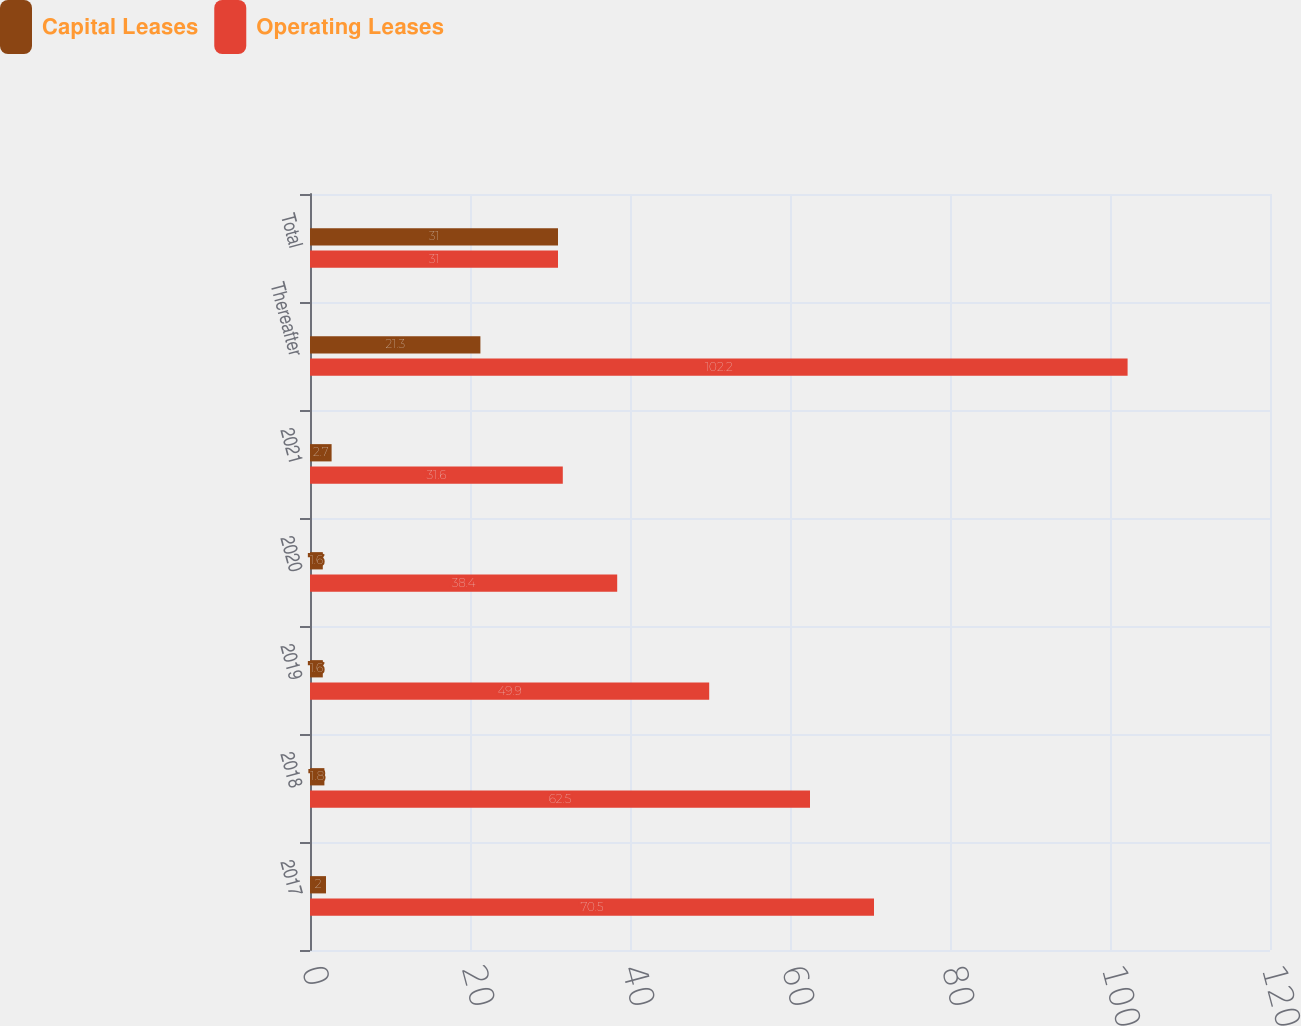Convert chart to OTSL. <chart><loc_0><loc_0><loc_500><loc_500><stacked_bar_chart><ecel><fcel>2017<fcel>2018<fcel>2019<fcel>2020<fcel>2021<fcel>Thereafter<fcel>Total<nl><fcel>Capital Leases<fcel>2<fcel>1.8<fcel>1.6<fcel>1.6<fcel>2.7<fcel>21.3<fcel>31<nl><fcel>Operating Leases<fcel>70.5<fcel>62.5<fcel>49.9<fcel>38.4<fcel>31.6<fcel>102.2<fcel>31<nl></chart> 